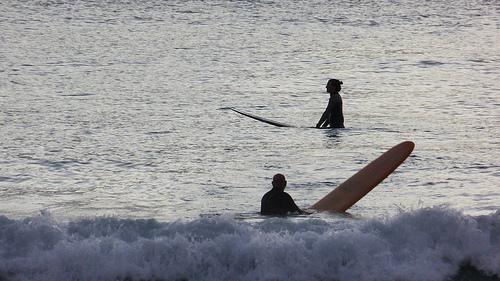Question: what do they surf on?
Choices:
A. Skin.
B. Trees.
C. Skimboards.
D. Surfboards.
Answer with the letter. Answer: D Question: who is pictured?
Choices:
A. Lawyers.
B. Chef.
C. Couple.
D. Surfers.
Answer with the letter. Answer: D Question: how is their appearance?
Choices:
A. Skinny.
B. Silhouette.
C. Fat.
D. Tired.
Answer with the letter. Answer: B Question: why are they there?
Choices:
A. Walking.
B. Sitting.
C. Playing.
D. Surfing.
Answer with the letter. Answer: D Question: where is this location?
Choices:
A. Beach.
B. Ocean.
C. Desert.
D. City.
Answer with the letter. Answer: B 